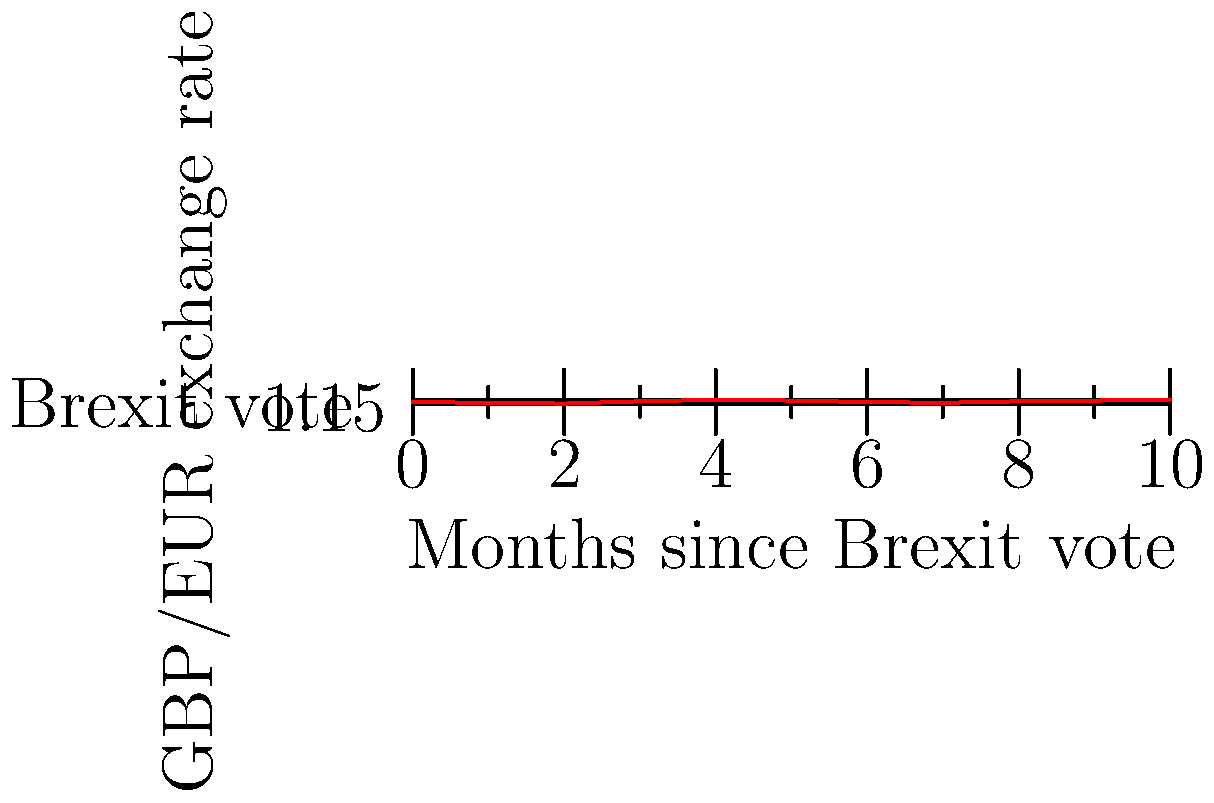The graph shows the fluctuations of the British Pound (GBP) against the Euro (EUR) in the months following the Brexit vote. What was the overall trend of the GBP/EUR exchange rate during this period, and what was the difference between the highest and lowest rates? To answer this question, we need to analyze the graph and follow these steps:

1. Identify the overall trend:
   - The graph starts at 1.15 and ends at 1.18
   - Despite fluctuations, there's a slight upward trend

2. Find the highest and lowest rates:
   - Lowest point: 1.13 (at month 2)
   - Highest point: 1.18 (at months 4 and 10)

3. Calculate the difference between the highest and lowest rates:
   $1.18 - 1.13 = 0.05$

Therefore, the overall trend was slightly upward, and the difference between the highest and lowest rates was 0.05.
Answer: Slight upward trend; 0.05 difference 